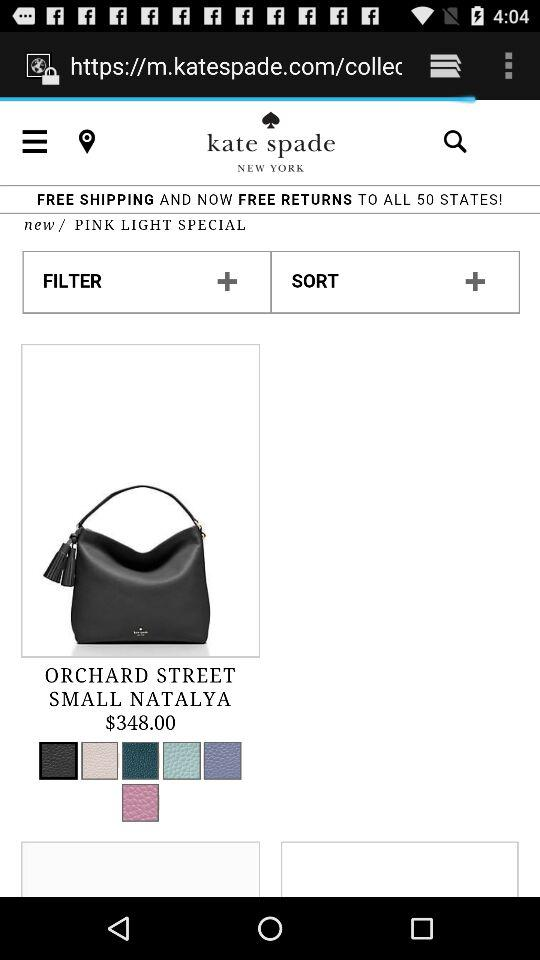Where is the store located? The store is located in New York. 